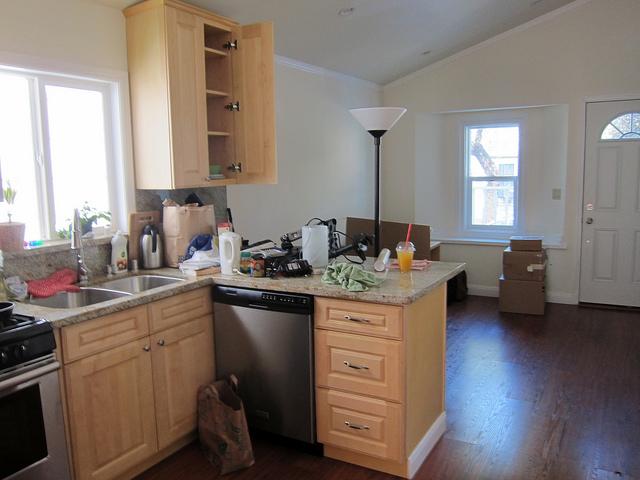What is the main color theme of the kitchen and living room?
Keep it brief. White. What piece of equipment is to the left of the sink and below?
Keep it brief. Stove. Is the floor lamp turned on?
Write a very short answer. No. Does someone live here?
Short answer required. Yes. How many windows do you see?
Answer briefly. 3. 